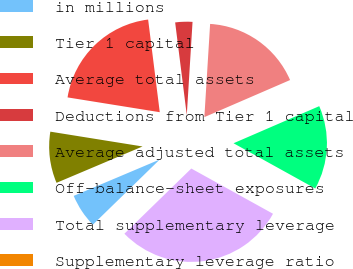Convert chart to OTSL. <chart><loc_0><loc_0><loc_500><loc_500><pie_chart><fcel>in millions<fcel>Tier 1 capital<fcel>Average total assets<fcel>Deductions from Tier 1 capital<fcel>Average adjusted total assets<fcel>Off-balance-sheet exposures<fcel>Total supplementary leverage<fcel>Supplementary leverage ratio<nl><fcel>5.93%<fcel>8.9%<fcel>20.48%<fcel>2.97%<fcel>17.52%<fcel>14.55%<fcel>29.66%<fcel>0.0%<nl></chart> 